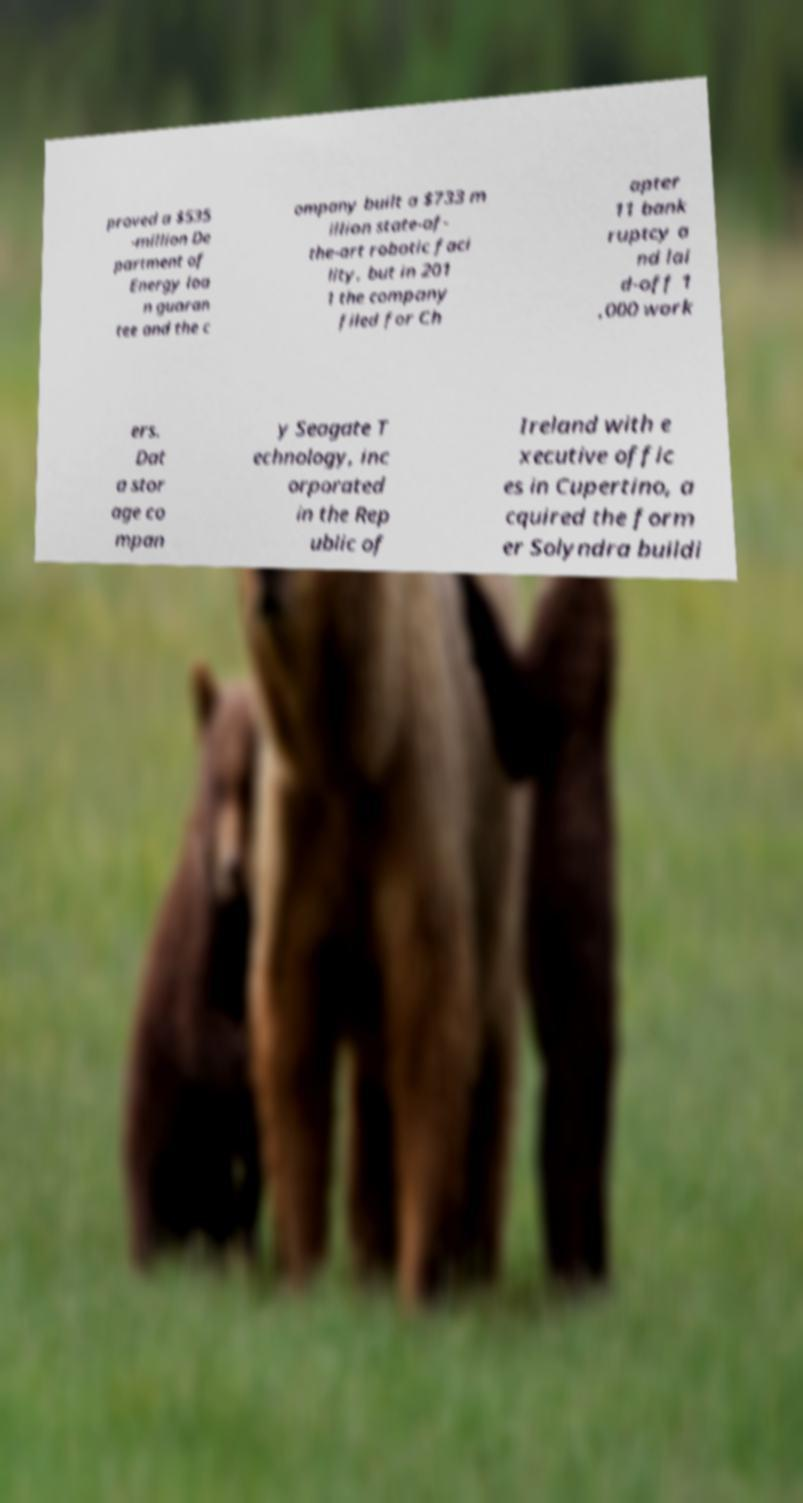I need the written content from this picture converted into text. Can you do that? proved a $535 -million De partment of Energy loa n guaran tee and the c ompany built a $733 m illion state-of- the-art robotic faci lity, but in 201 1 the company filed for Ch apter 11 bank ruptcy a nd lai d-off 1 ,000 work ers. Dat a stor age co mpan y Seagate T echnology, inc orporated in the Rep ublic of Ireland with e xecutive offic es in Cupertino, a cquired the form er Solyndra buildi 